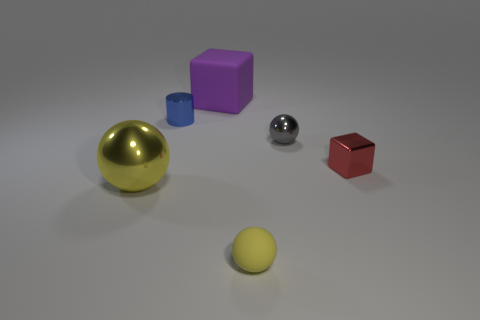There is a yellow ball left of the purple object; does it have the same size as the large purple matte cube?
Offer a terse response. Yes. What is the shape of the object that is behind the small gray ball and in front of the large matte thing?
Keep it short and to the point. Cylinder. Do the tiny metal block and the rubber thing that is on the left side of the yellow matte thing have the same color?
Provide a short and direct response. No. What is the color of the matte thing that is behind the big thing in front of the big thing behind the large yellow sphere?
Offer a very short reply. Purple. What is the color of the large metallic object that is the same shape as the yellow matte thing?
Ensure brevity in your answer.  Yellow. Is the number of big things that are in front of the tiny matte ball the same as the number of metal cubes?
Provide a short and direct response. No. How many balls are big red things or small yellow objects?
Your answer should be very brief. 1. There is a sphere that is the same material as the big purple object; what color is it?
Your answer should be very brief. Yellow. Is the material of the big yellow ball the same as the large block right of the big ball?
Make the answer very short. No. What number of objects are either red rubber cylinders or small red blocks?
Make the answer very short. 1. 